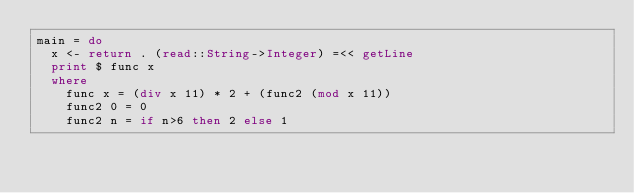Convert code to text. <code><loc_0><loc_0><loc_500><loc_500><_Haskell_>main = do
  x <- return . (read::String->Integer) =<< getLine
  print $ func x
  where
    func x = (div x 11) * 2 + (func2 (mod x 11))
    func2 0 = 0
    func2 n = if n>6 then 2 else 1
</code> 